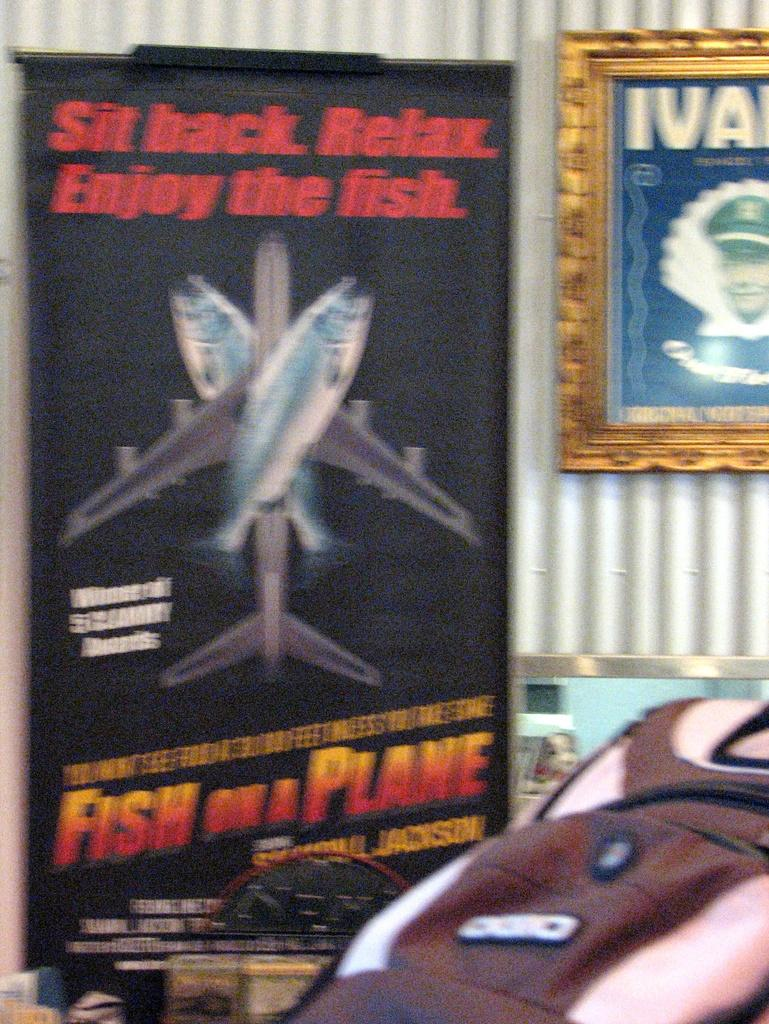<image>
Give a short and clear explanation of the subsequent image. A poster for the film Fish on a Plane that has a plane with fish on it. 